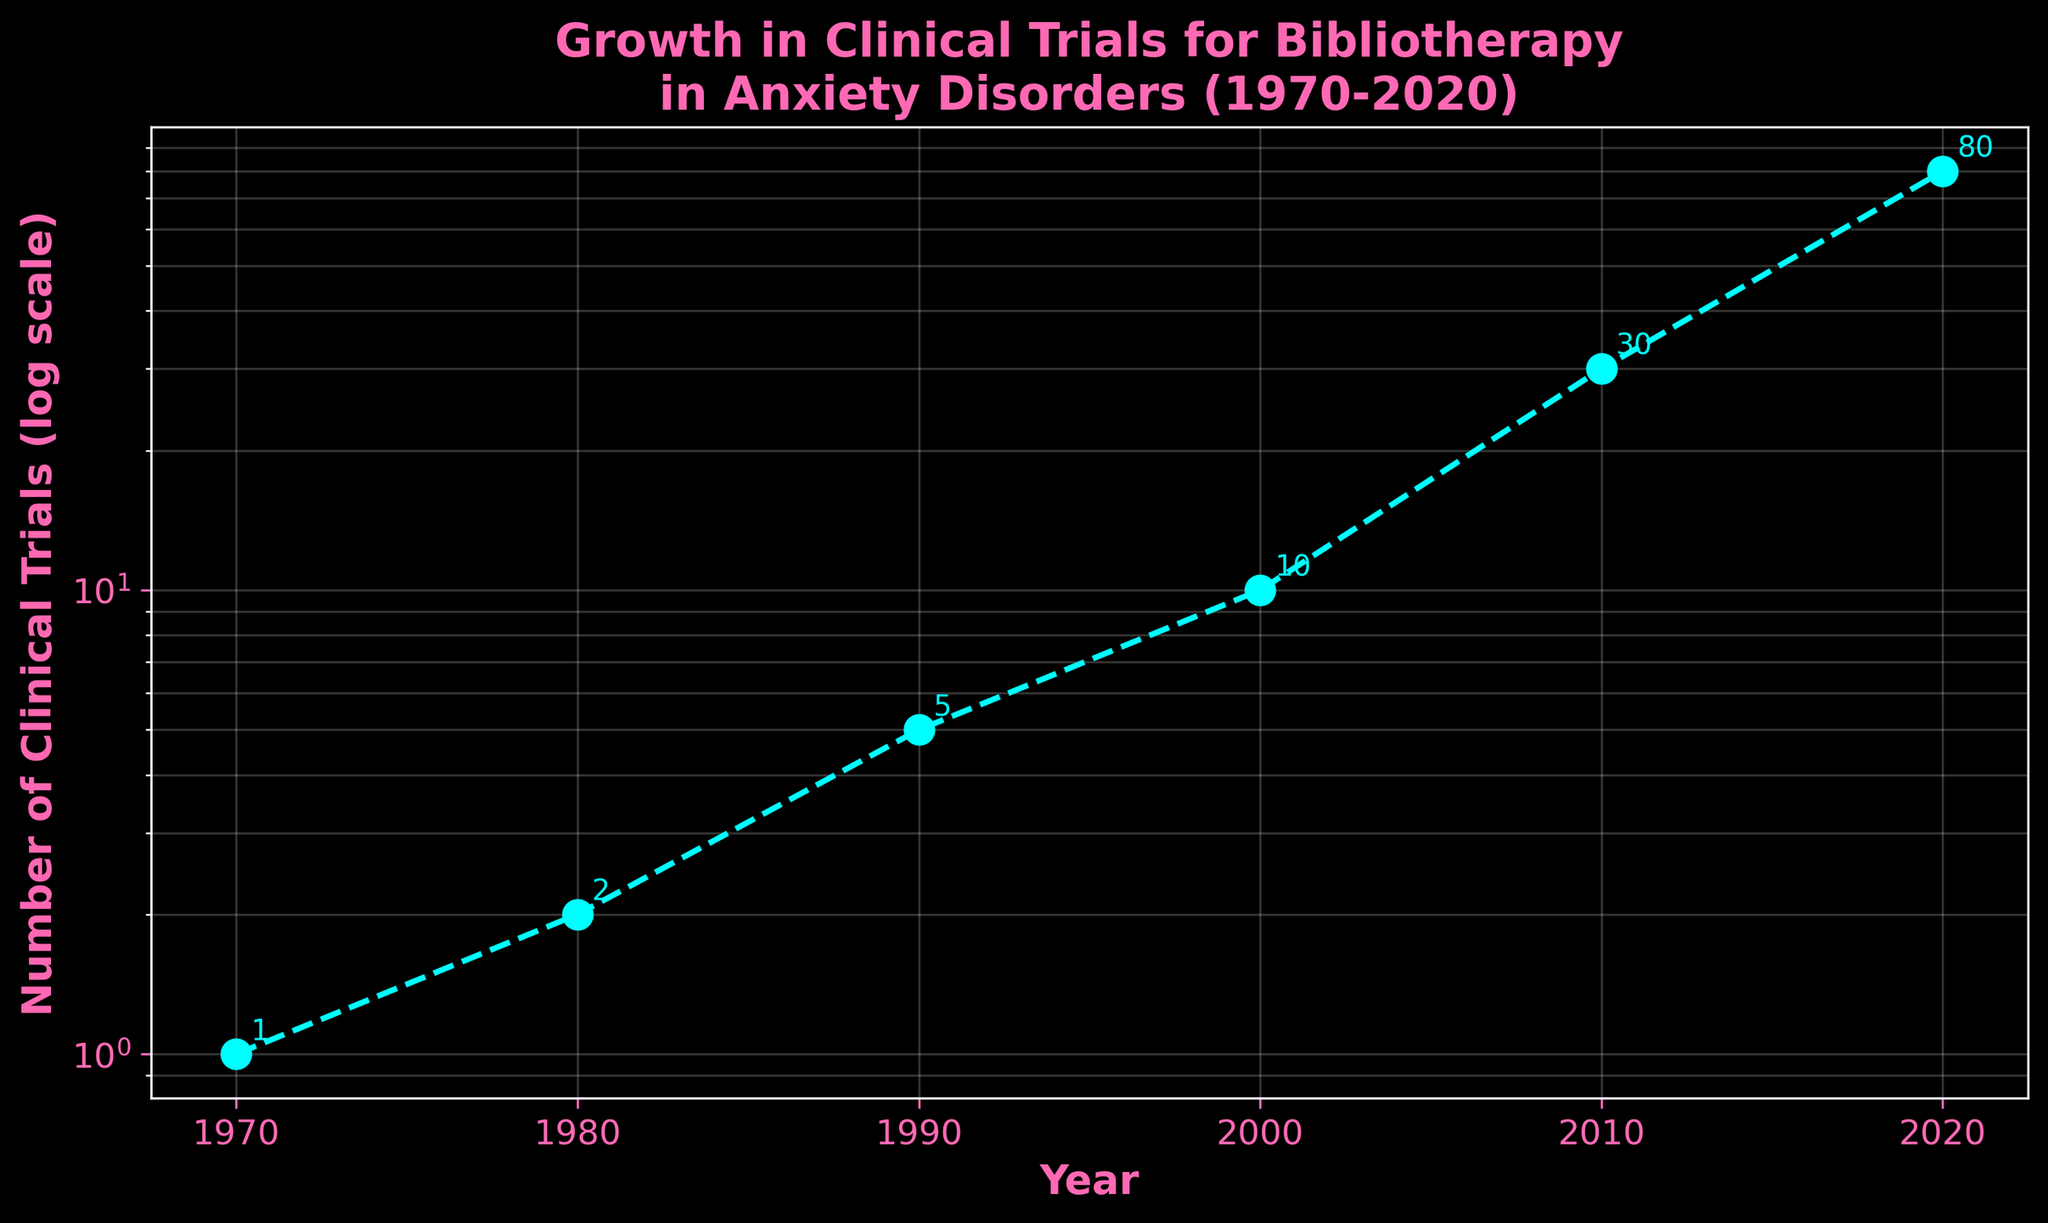what is the title of the figure? The title is displayed at the top of the figure in bold pink text, indicating the theme of the plot.
Answer: Growth in Clinical Trials for Bibliotherapy in Anxiety Disorders (1970-2020) how many data points are plotted in the figure? By counting the markers on the plotted line, you can see there are 6 data points.
Answer: 6 what is the value of the number of clinical trials in 2010? Locate the year 2010 on the x-axis and refer to the corresponding y-coordinate. The annotation next to the marker shows the value as 30.
Answer: 30 how much did the number of clinical trials grow between 1980 and 2000? Find the values for 1980 and 2000 from the y-axis or annotations (2 and 10, respectively). Subtract the former from the latter: 10 - 2 = 8.
Answer: 8 which decade experienced the highest increase in the number of clinical trials? Compare the growth across decades: 1970-1980 (1 to 2, increase of 1), 1980-1990 (2 to 5, increase of 3), 1990-2000 (5 to 10, increase of 5), 2000-2010 (10 to 30, increase of 20), 2010-2020 (30 to 80, increase of 50). The highest increase is in the 2010-2020 period.
Answer: 2010-2020 what visual style and color theme are used in the figure? The figure uses a dark background theme, with a cyan line and pink text for labels and title.
Answer: Dark background with cyan and pink colors how is the data trend represented in the plot? The data trend is represented by a cyan dashed line with circular markers indicating data points.
Answer: Cyan dashed line with markers how would the plot appear if the y-axis were not on a log scale? If the y-axis were not on a log scale, the exponential growth would make the latter values (like 80 in 2020) much higher and the earlier values (like 1 in 1970) almost indistinguishable, resulting in a steep ascending curve.
Answer: Steeply ascending curve with the earlier values barely distinguishable what is the average number of clinical trials per decade? Sum the total number of trials (1+2+5+10+30+80=128) and divide by the number of decades (6): 128 / 6 ≈ 21.33.
Answer: Approximately 21.33 what does the y-axis label indicate about the values plotted? The y-axis label specifies a log scale, indicating that the values increase exponentially rather than linearly.
Answer: Values increase exponentially 